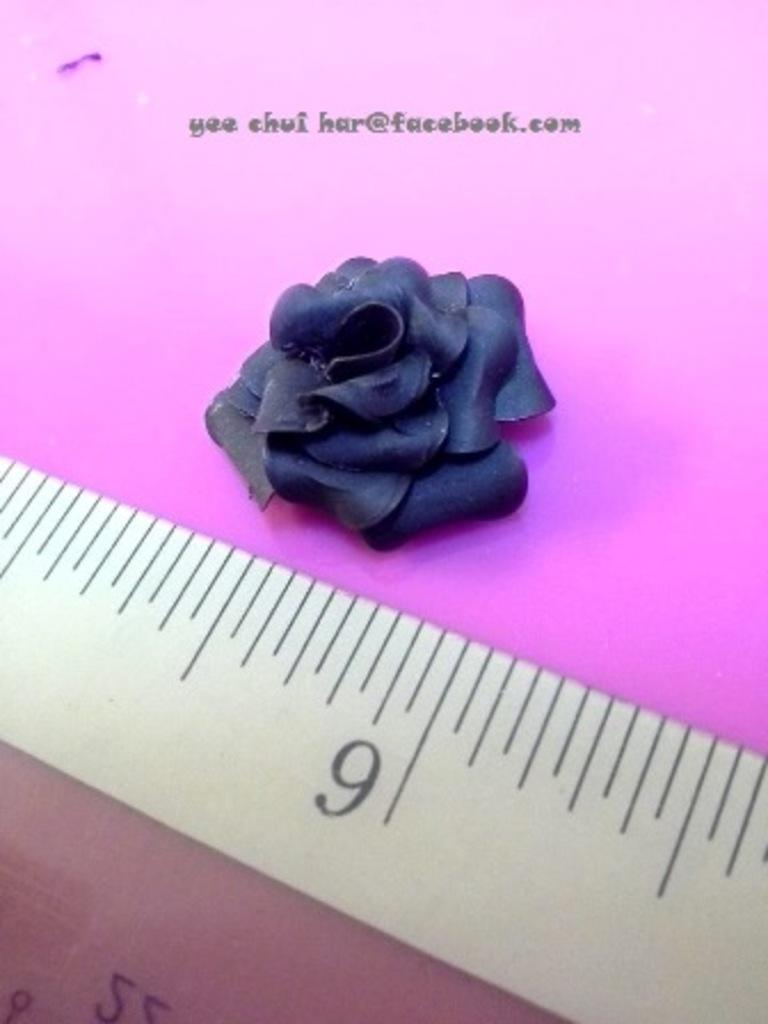What object is present in the image that is used for measuring weight? There is a scale in the image. What type of plant is visible in the image? There is a flower in the image. What is the color of the flower? The flower is black in color. What color is the surface that the flower is placed on? There is a pink color surface in the image. What day of the week is depicted in the image? There is no day of the week depicted in the image. What type of chain is present in the image? There is no chain present in the image. 